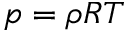<formula> <loc_0><loc_0><loc_500><loc_500>p = \rho R T</formula> 